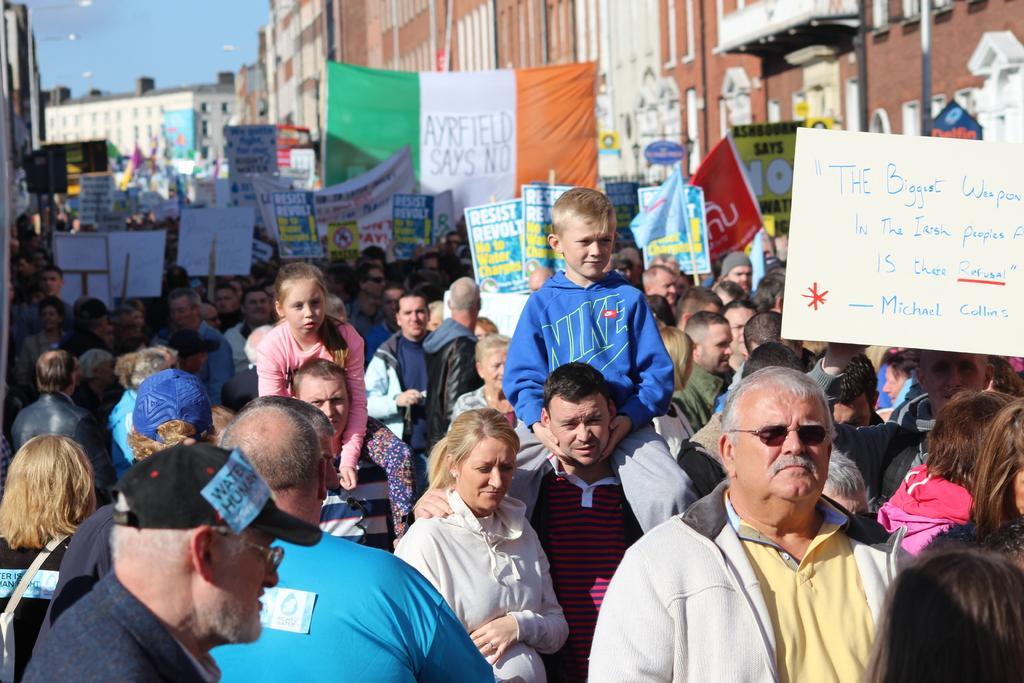Describe this image in one or two sentences. In this image we can see some people among them few people are holding boards and on the boards we can see some text. There are some buildings in the background. 